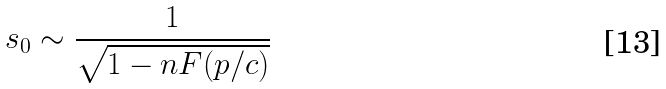Convert formula to latex. <formula><loc_0><loc_0><loc_500><loc_500>s _ { 0 } \sim \frac { 1 } { \sqrt { 1 - n F ( p / c ) } }</formula> 